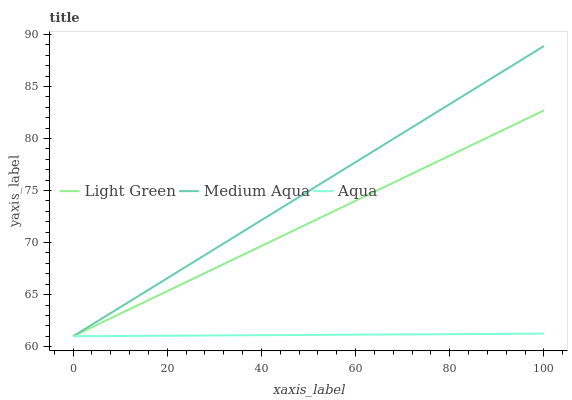Does Light Green have the minimum area under the curve?
Answer yes or no. No. Does Light Green have the maximum area under the curve?
Answer yes or no. No. Is Medium Aqua the smoothest?
Answer yes or no. No. Is Medium Aqua the roughest?
Answer yes or no. No. Does Light Green have the highest value?
Answer yes or no. No. 